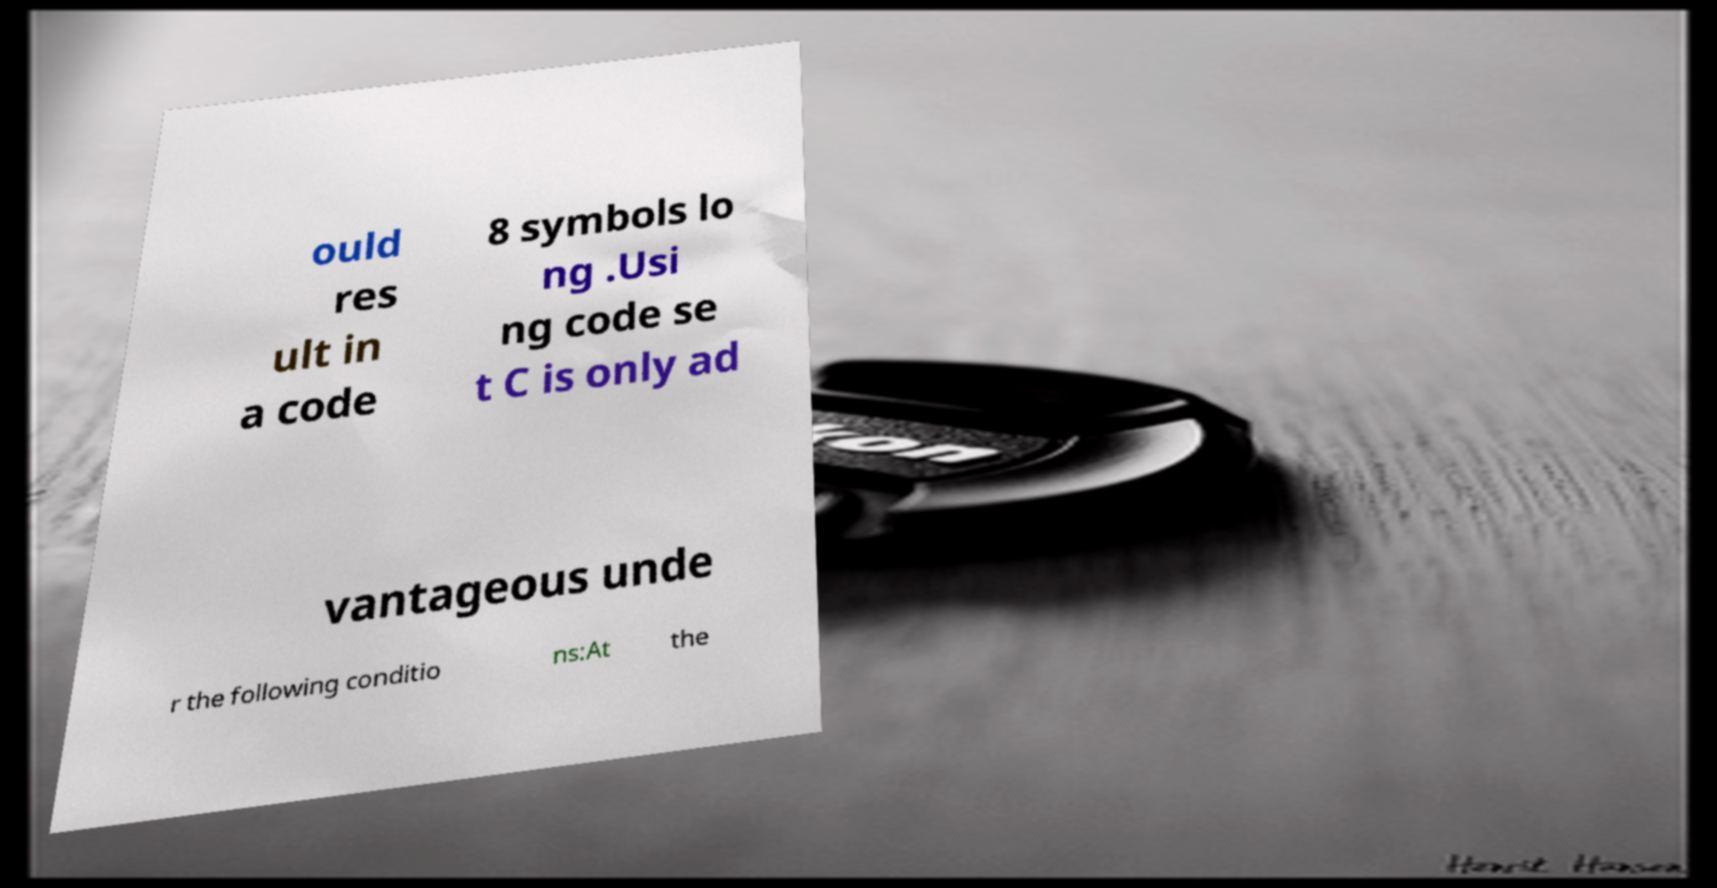I need the written content from this picture converted into text. Can you do that? ould res ult in a code 8 symbols lo ng .Usi ng code se t C is only ad vantageous unde r the following conditio ns:At the 